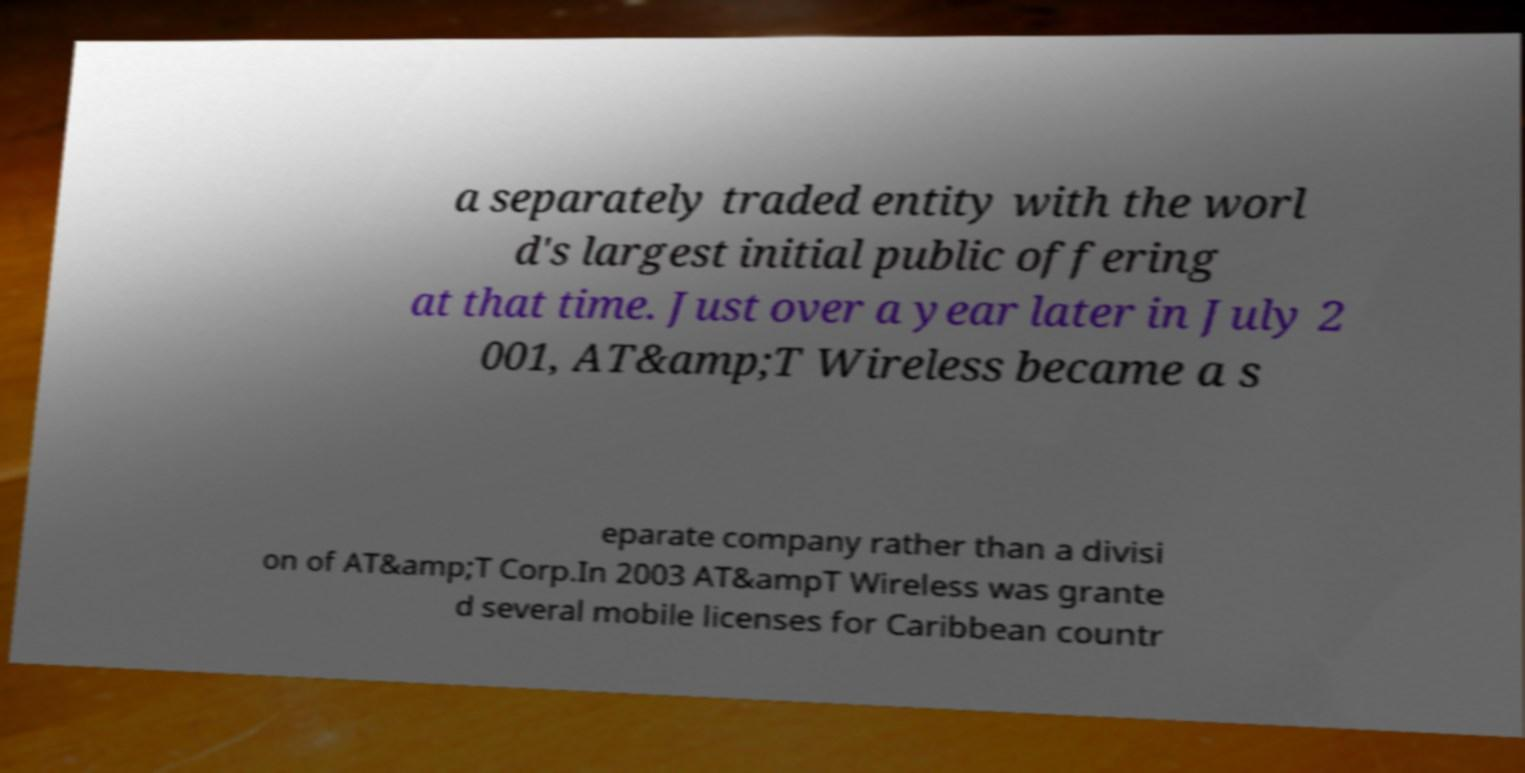I need the written content from this picture converted into text. Can you do that? a separately traded entity with the worl d's largest initial public offering at that time. Just over a year later in July 2 001, AT&amp;T Wireless became a s eparate company rather than a divisi on of AT&amp;T Corp.In 2003 AT&ampT Wireless was grante d several mobile licenses for Caribbean countr 